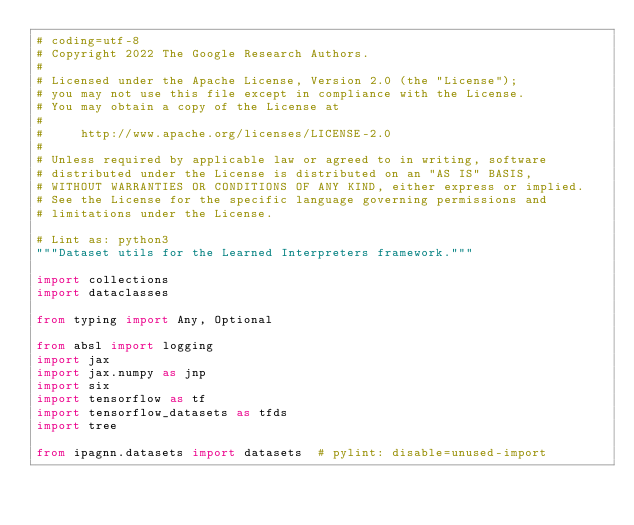Convert code to text. <code><loc_0><loc_0><loc_500><loc_500><_Python_># coding=utf-8
# Copyright 2022 The Google Research Authors.
#
# Licensed under the Apache License, Version 2.0 (the "License");
# you may not use this file except in compliance with the License.
# You may obtain a copy of the License at
#
#     http://www.apache.org/licenses/LICENSE-2.0
#
# Unless required by applicable law or agreed to in writing, software
# distributed under the License is distributed on an "AS IS" BASIS,
# WITHOUT WARRANTIES OR CONDITIONS OF ANY KIND, either express or implied.
# See the License for the specific language governing permissions and
# limitations under the License.

# Lint as: python3
"""Dataset utils for the Learned Interpreters framework."""

import collections
import dataclasses

from typing import Any, Optional

from absl import logging
import jax
import jax.numpy as jnp
import six
import tensorflow as tf
import tensorflow_datasets as tfds
import tree

from ipagnn.datasets import datasets  # pylint: disable=unused-import

</code> 